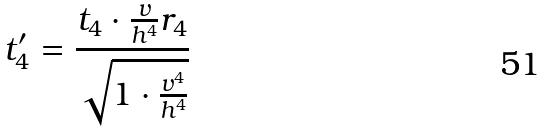Convert formula to latex. <formula><loc_0><loc_0><loc_500><loc_500>t _ { 4 } ^ { \prime } = \frac { t _ { 4 } \cdot \frac { v } { h ^ { 4 } } r _ { 4 } } { \sqrt { 1 \cdot \frac { v ^ { 4 } } { h ^ { 4 } } } }</formula> 